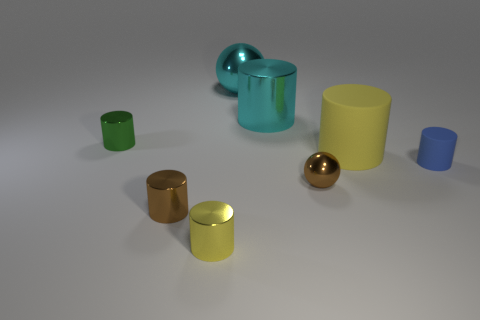Subtract 2 cylinders. How many cylinders are left? 4 Subtract all green cylinders. How many cylinders are left? 5 Subtract all brown metallic cylinders. How many cylinders are left? 5 Subtract all red cylinders. Subtract all green cubes. How many cylinders are left? 6 Add 1 yellow spheres. How many objects exist? 9 Subtract all balls. How many objects are left? 6 Add 5 large cyan shiny balls. How many large cyan shiny balls are left? 6 Add 1 brown cylinders. How many brown cylinders exist? 2 Subtract 0 green blocks. How many objects are left? 8 Subtract all things. Subtract all big blue objects. How many objects are left? 0 